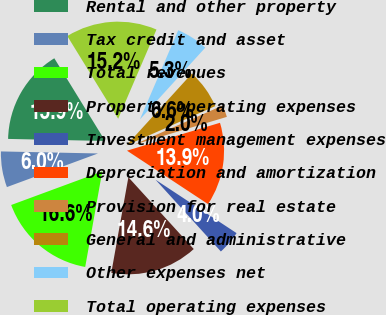<chart> <loc_0><loc_0><loc_500><loc_500><pie_chart><fcel>Rental and other property<fcel>Tax credit and asset<fcel>Total revenues<fcel>Property operating expenses<fcel>Investment management expenses<fcel>Depreciation and amortization<fcel>Provision for real estate<fcel>General and administrative<fcel>Other expenses net<fcel>Total operating expenses<nl><fcel>15.89%<fcel>5.96%<fcel>16.56%<fcel>14.57%<fcel>3.97%<fcel>13.91%<fcel>1.99%<fcel>6.62%<fcel>5.3%<fcel>15.23%<nl></chart> 